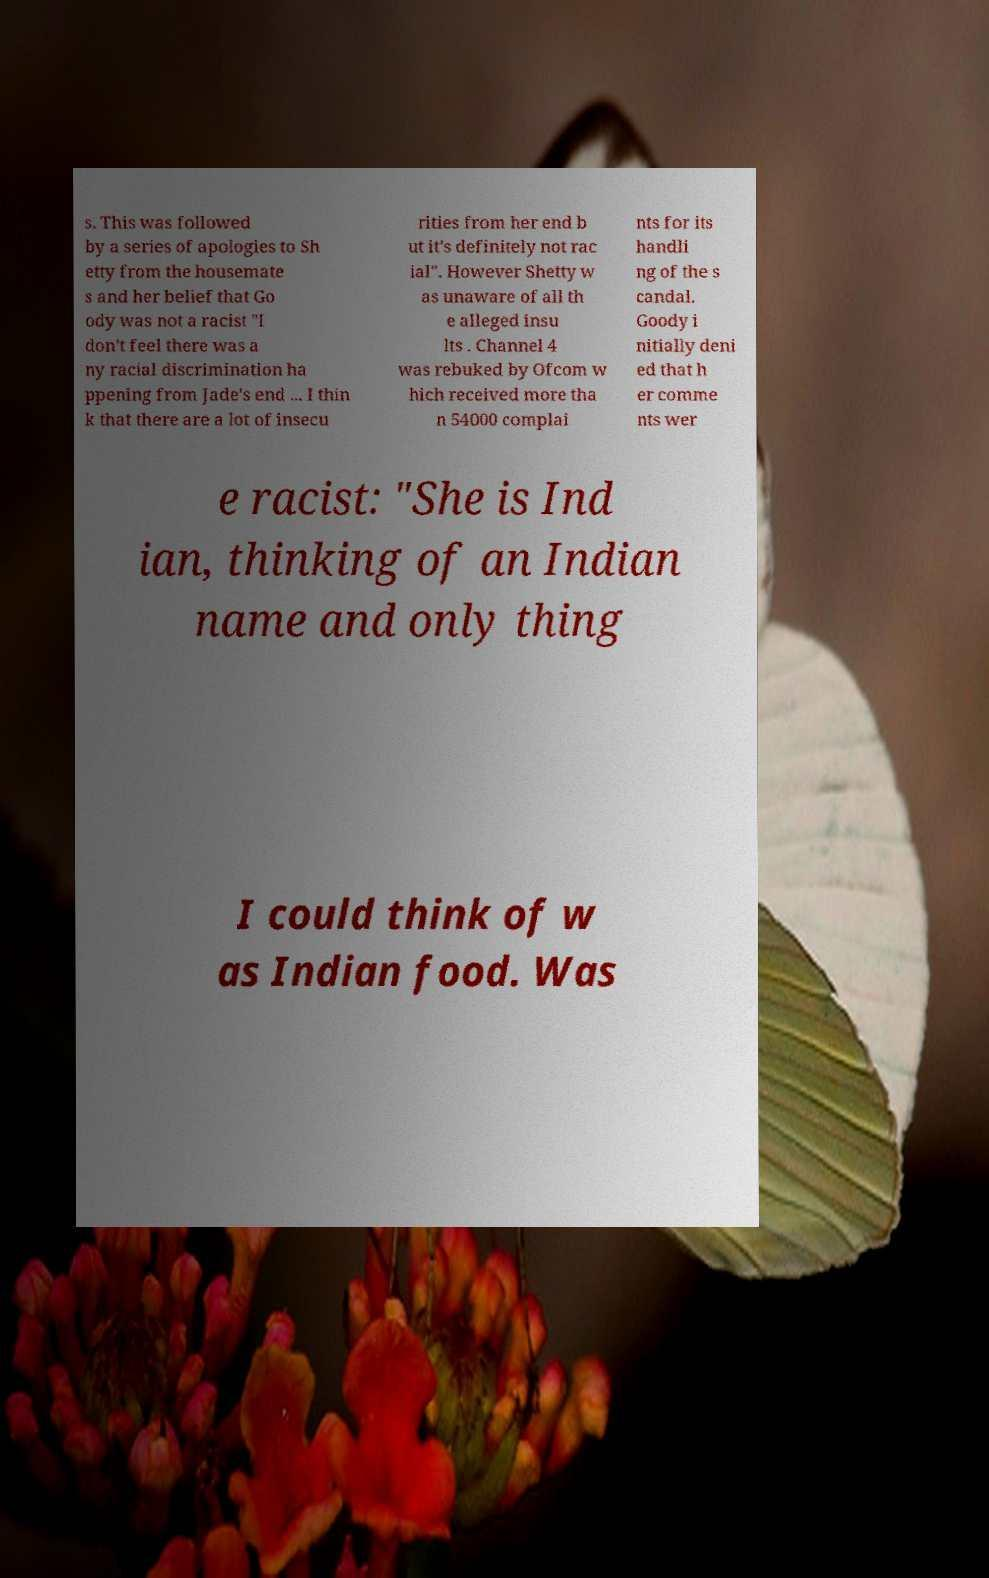There's text embedded in this image that I need extracted. Can you transcribe it verbatim? s. This was followed by a series of apologies to Sh etty from the housemate s and her belief that Go ody was not a racist "I don't feel there was a ny racial discrimination ha ppening from Jade's end ... I thin k that there are a lot of insecu rities from her end b ut it's definitely not rac ial". However Shetty w as unaware of all th e alleged insu lts . Channel 4 was rebuked by Ofcom w hich received more tha n 54000 complai nts for its handli ng of the s candal. Goody i nitially deni ed that h er comme nts wer e racist: "She is Ind ian, thinking of an Indian name and only thing I could think of w as Indian food. Was 